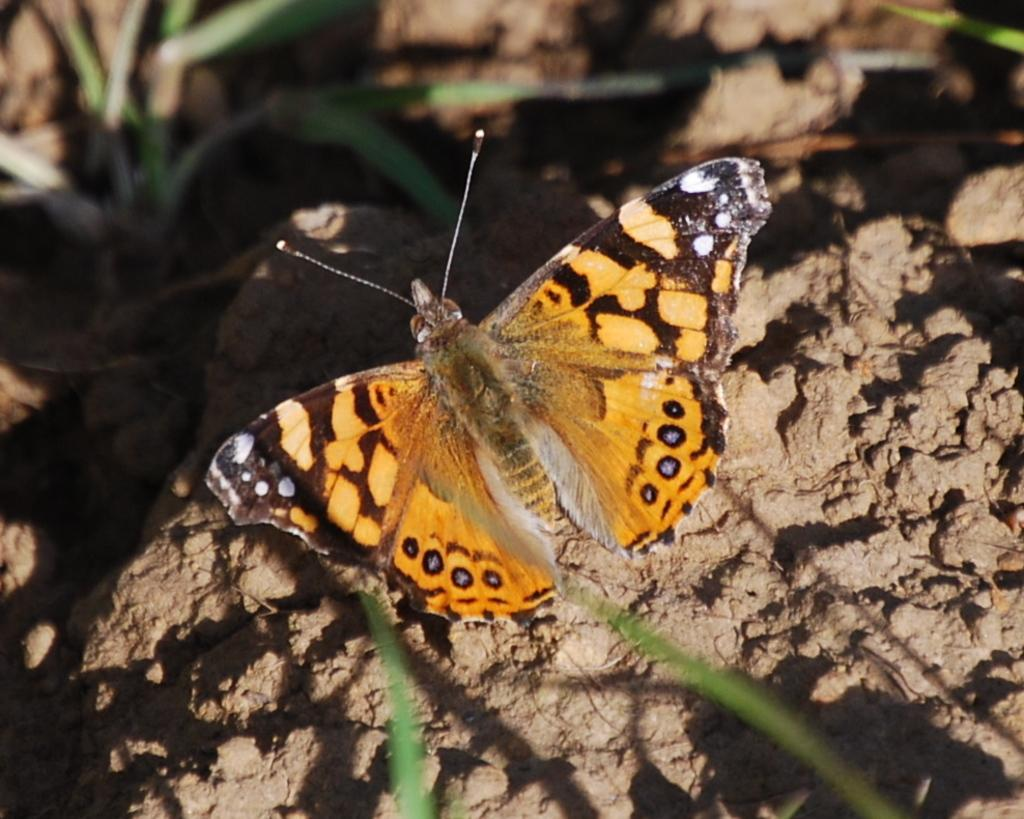What is the main subject of the image? There is a butterfly in the image. Where is the butterfly located? The butterfly is sitting on a stone. Can you describe the background of the image? The background of the image is blurred. What type of bait is the butterfly using to catch fish in the image? There is no bait or fish present in the image; it features a butterfly sitting on a stone. Can you tell me how many horses are visible in the image? There are no horses present in the image. 